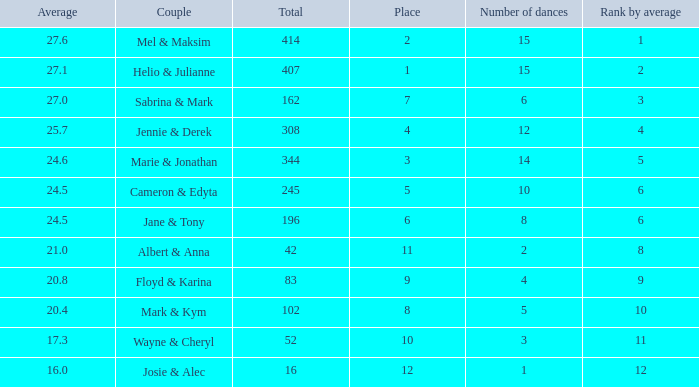What is the smallest place number when the total is 16 and average is less than 16? None. 